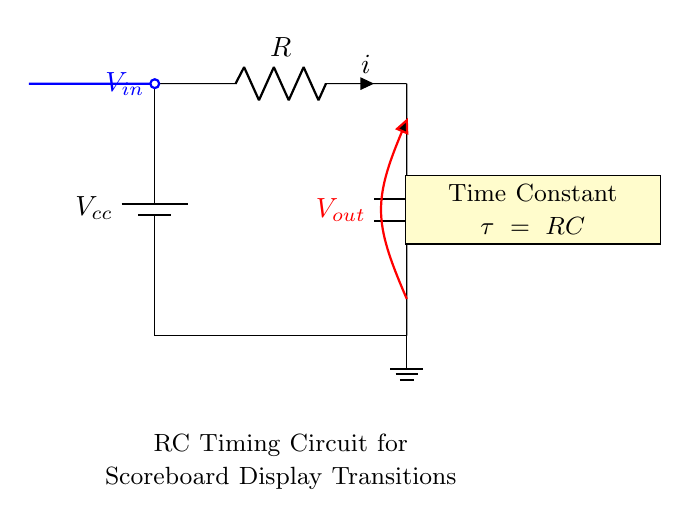What type of components are used in this circuit? The circuit uses a resistor and a capacitor, which are the primary components indicated in the diagram. The resistor is labeled with R and the capacitor with C.
Answer: Resistor and Capacitor What is the role of the capacitor in this RC timing circuit? The capacitor in an RC timing circuit primarily serves to store and discharge electrical energy, which affects the timing of the voltage transition at the output. Its charging and discharging determine the time constant for the display transitions.
Answer: Store electrical energy What is the time constant of this circuit? The time constant τ is calculated as the product of the resistance value R and the capacitance value C. This is explicitly noted in the circuit with the formula τ = RC.
Answer: RC What input signal is used for the circuit? The circuit has an input signal labeled V-in that is applied to the circuit, which influences the output voltage V-out as the capacitor charges and discharges.
Answer: V-in How does an increase in resistance affect the timing of the circuit? Increasing the resistance R results in a higher time constant τ (since τ = RC), which means the capacitor will take longer to charge and discharge, leading to slower display transitions on the scoreboard.
Answer: Slower transitions What does V-out signify in the circuit? The output voltage V-out indicates the voltage at the output of the capacitor, which reflects the time-based changes as it charges and discharges in response to V-in.
Answer: Output voltage Which direction does the current flow in this circuit? The current flows from the positive terminal of the battery through the resistor R, then through the capacitor C to ground, completing the circuit.
Answer: From battery to ground 